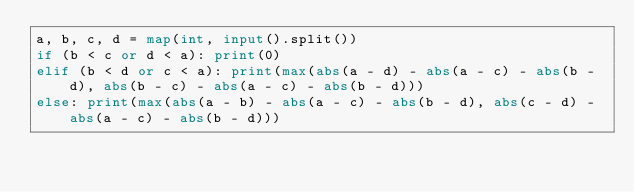<code> <loc_0><loc_0><loc_500><loc_500><_Python_>a, b, c, d = map(int, input().split())
if (b < c or d < a): print(0)
elif (b < d or c < a): print(max(abs(a - d) - abs(a - c) - abs(b - d), abs(b - c) - abs(a - c) - abs(b - d)))
else: print(max(abs(a - b) - abs(a - c) - abs(b - d), abs(c - d) - abs(a - c) - abs(b - d)))
</code> 